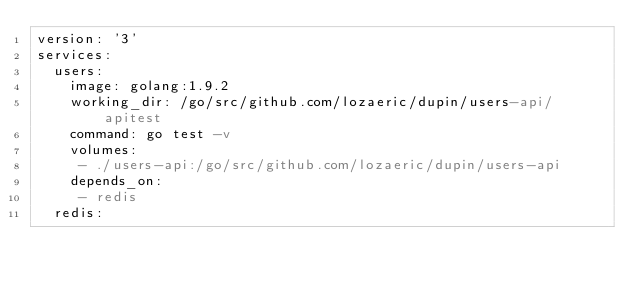Convert code to text. <code><loc_0><loc_0><loc_500><loc_500><_YAML_>version: '3'
services:
  users:
    image: golang:1.9.2
    working_dir: /go/src/github.com/lozaeric/dupin/users-api/apitest
    command: go test -v
    volumes:
     - ./users-api:/go/src/github.com/lozaeric/dupin/users-api
    depends_on:
     - redis
  redis:</code> 